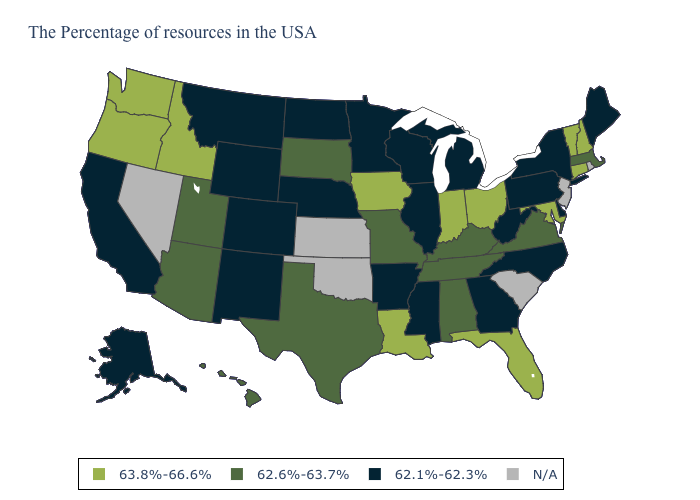Among the states that border Arizona , does Utah have the highest value?
Concise answer only. Yes. Does Wyoming have the lowest value in the West?
Be succinct. Yes. Name the states that have a value in the range 62.1%-62.3%?
Keep it brief. Maine, New York, Delaware, Pennsylvania, North Carolina, West Virginia, Georgia, Michigan, Wisconsin, Illinois, Mississippi, Arkansas, Minnesota, Nebraska, North Dakota, Wyoming, Colorado, New Mexico, Montana, California, Alaska. Does New Hampshire have the lowest value in the Northeast?
Keep it brief. No. What is the highest value in the USA?
Be succinct. 63.8%-66.6%. What is the lowest value in the Northeast?
Concise answer only. 62.1%-62.3%. Among the states that border North Dakota , which have the lowest value?
Concise answer only. Minnesota, Montana. Name the states that have a value in the range 63.8%-66.6%?
Quick response, please. New Hampshire, Vermont, Connecticut, Maryland, Ohio, Florida, Indiana, Louisiana, Iowa, Idaho, Washington, Oregon. Name the states that have a value in the range 62.1%-62.3%?
Short answer required. Maine, New York, Delaware, Pennsylvania, North Carolina, West Virginia, Georgia, Michigan, Wisconsin, Illinois, Mississippi, Arkansas, Minnesota, Nebraska, North Dakota, Wyoming, Colorado, New Mexico, Montana, California, Alaska. Among the states that border Kentucky , does West Virginia have the highest value?
Answer briefly. No. How many symbols are there in the legend?
Short answer required. 4. Name the states that have a value in the range 62.6%-63.7%?
Write a very short answer. Massachusetts, Virginia, Kentucky, Alabama, Tennessee, Missouri, Texas, South Dakota, Utah, Arizona, Hawaii. What is the value of Arizona?
Be succinct. 62.6%-63.7%. What is the highest value in the Northeast ?
Short answer required. 63.8%-66.6%. 